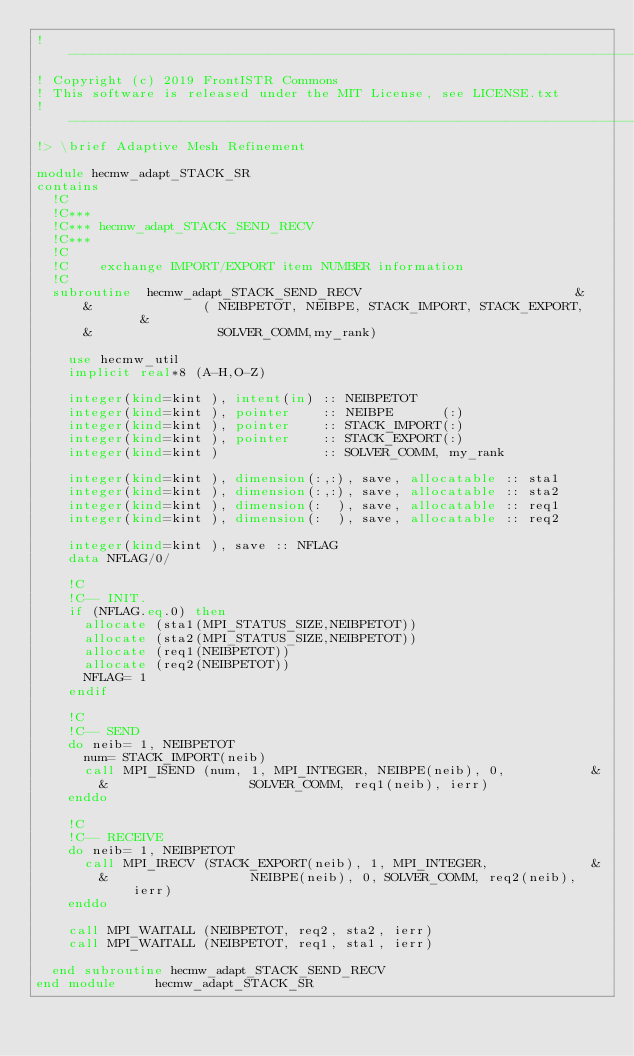<code> <loc_0><loc_0><loc_500><loc_500><_FORTRAN_>!-------------------------------------------------------------------------------
! Copyright (c) 2019 FrontISTR Commons
! This software is released under the MIT License, see LICENSE.txt
!-------------------------------------------------------------------------------
!> \brief Adaptive Mesh Refinement

module hecmw_adapt_STACK_SR
contains
  !C
  !C***
  !C*** hecmw_adapt_STACK_SEND_RECV
  !C***
  !C
  !C    exchange IMPORT/EXPORT item NUMBER information
  !C
  subroutine  hecmw_adapt_STACK_SEND_RECV                           &
      &              ( NEIBPETOT, NEIBPE, STACK_IMPORT, STACK_EXPORT,    &
      &                SOLVER_COMM,my_rank)

    use hecmw_util
    implicit real*8 (A-H,O-Z)

    integer(kind=kint ), intent(in) :: NEIBPETOT
    integer(kind=kint ), pointer    :: NEIBPE      (:)
    integer(kind=kint ), pointer    :: STACK_IMPORT(:)
    integer(kind=kint ), pointer    :: STACK_EXPORT(:)
    integer(kind=kint )             :: SOLVER_COMM, my_rank

    integer(kind=kint ), dimension(:,:), save, allocatable :: sta1
    integer(kind=kint ), dimension(:,:), save, allocatable :: sta2
    integer(kind=kint ), dimension(:  ), save, allocatable :: req1
    integer(kind=kint ), dimension(:  ), save, allocatable :: req2

    integer(kind=kint ), save :: NFLAG
    data NFLAG/0/

    !C
    !C-- INIT.
    if (NFLAG.eq.0) then
      allocate (sta1(MPI_STATUS_SIZE,NEIBPETOT))
      allocate (sta2(MPI_STATUS_SIZE,NEIBPETOT))
      allocate (req1(NEIBPETOT))
      allocate (req2(NEIBPETOT))
      NFLAG= 1
    endif

    !C
    !C-- SEND
    do neib= 1, NEIBPETOT
      num= STACK_IMPORT(neib)
      call MPI_ISEND (num, 1, MPI_INTEGER, NEIBPE(neib), 0,           &
        &                  SOLVER_COMM, req1(neib), ierr)
    enddo

    !C
    !C-- RECEIVE
    do neib= 1, NEIBPETOT
      call MPI_IRECV (STACK_EXPORT(neib), 1, MPI_INTEGER,             &
        &                  NEIBPE(neib), 0, SOLVER_COMM, req2(neib), ierr)
    enddo

    call MPI_WAITALL (NEIBPETOT, req2, sta2, ierr)
    call MPI_WAITALL (NEIBPETOT, req1, sta1, ierr)

  end subroutine hecmw_adapt_STACK_SEND_RECV
end module     hecmw_adapt_STACK_SR



</code> 